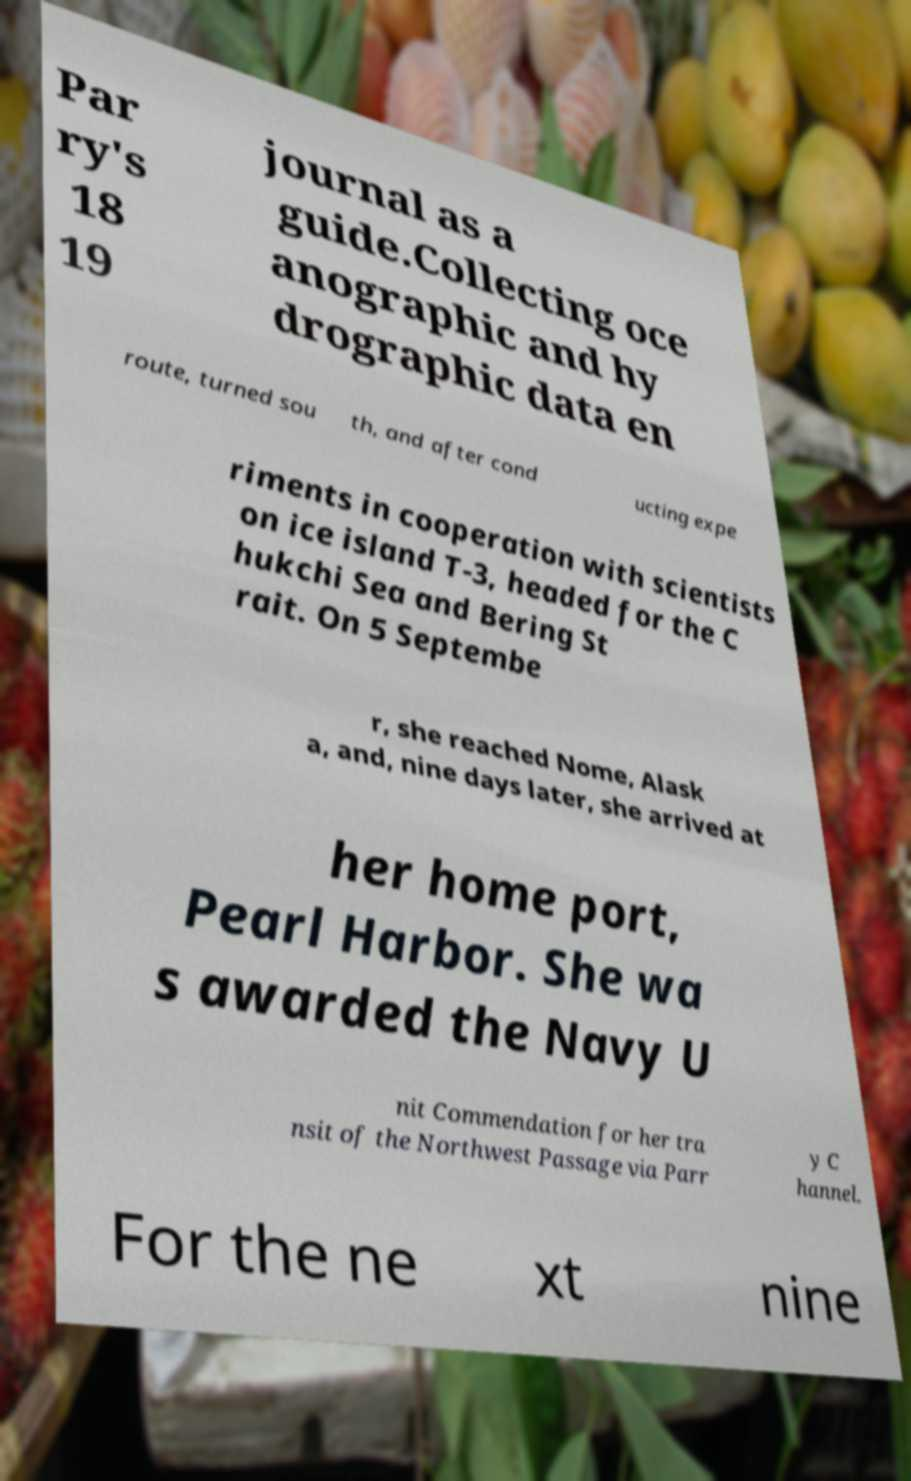Can you read and provide the text displayed in the image?This photo seems to have some interesting text. Can you extract and type it out for me? Par ry's 18 19 journal as a guide.Collecting oce anographic and hy drographic data en route, turned sou th, and after cond ucting expe riments in cooperation with scientists on ice island T-3, headed for the C hukchi Sea and Bering St rait. On 5 Septembe r, she reached Nome, Alask a, and, nine days later, she arrived at her home port, Pearl Harbor. She wa s awarded the Navy U nit Commendation for her tra nsit of the Northwest Passage via Parr y C hannel. For the ne xt nine 